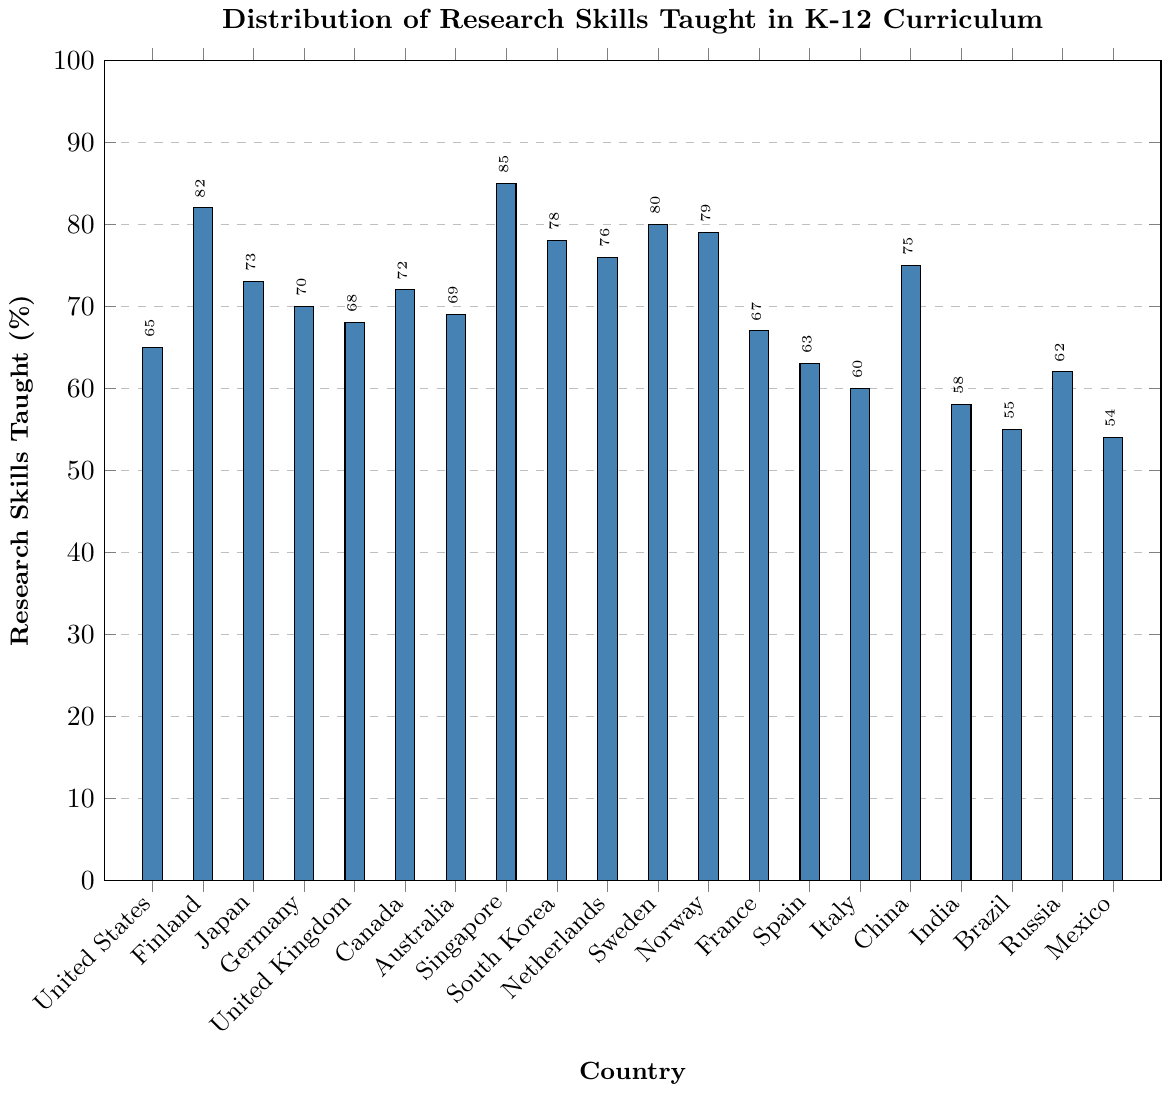What is the percentage of research skills taught in Finland? To find the percentage of research skills taught in Finland, locate Finland on the x-axis and read the corresponding bar height on the y-axis.
Answer: 82 Which country has the highest percentage of research skills taught? Look for the tallest bar in the bar chart and identify the country on the x-axis beneath this bar.
Answer: Singapore How much higher is the percentage of research skills taught in Norway compared to Mexico? Find the heights of the bars for Norway and Mexico. Norway is 79% and Mexico is 54%. Calculate the difference: 79% - 54% = 25%.
Answer: 25% What is the average percentage of research skills taught across the United States, United Kingdom, and Canada? Add the percentages for these countries: 65% (US) + 68% (UK) + 72% (Canada) = 205%. Divide by 3 to find the average: 205% / 3 = ≈ 68.33%.
Answer: ≈ 68.33% Which countries have a higher percentage of research skills taught than Japan? Identify Japan's percentage (73%) and then list all countries with a higher percentage by comparing their bar heights. These countries are Finland (82%), Singapore (85%), South Korea (78%), Sweden (80%), Norway (79%), and China (75%).
Answer: Finland, Singapore, South Korea, Sweden, Norway, China How many countries have less than 60% of research skills taught? Count the bars that are below the 60% mark on the y-axis. These countries are India (58%), Brazil (55%), Russia (62% - excluded since it is showing above 60%) and Mexico (54%). Mexico and Brazil are below 60%.
Answer: 3 What is the combined percentage of research skills taught for Sweden and Japan? Add the percentages of research skills taught in Sweden (80%) and Japan (73%). 80% + 73% = 153%.
Answer: 153% Between Italy and Australia, which country has a lower percentage of research skills taught? Compare the heights of the bars for Italy and Australia. Italy’s bar height is 60%, and Australia’s bar height is 69%. Italy is lower.
Answer: Italy What is the range of the percentages of research skills taught across all the countries? Find the smallest and largest percentages in the data. The smallest is Mexico (54%) and the largest is Singapore (85%). Calculate the range by subtracting the smallest from the largest: 85% - 54% = 31%.
Answer: 31% 